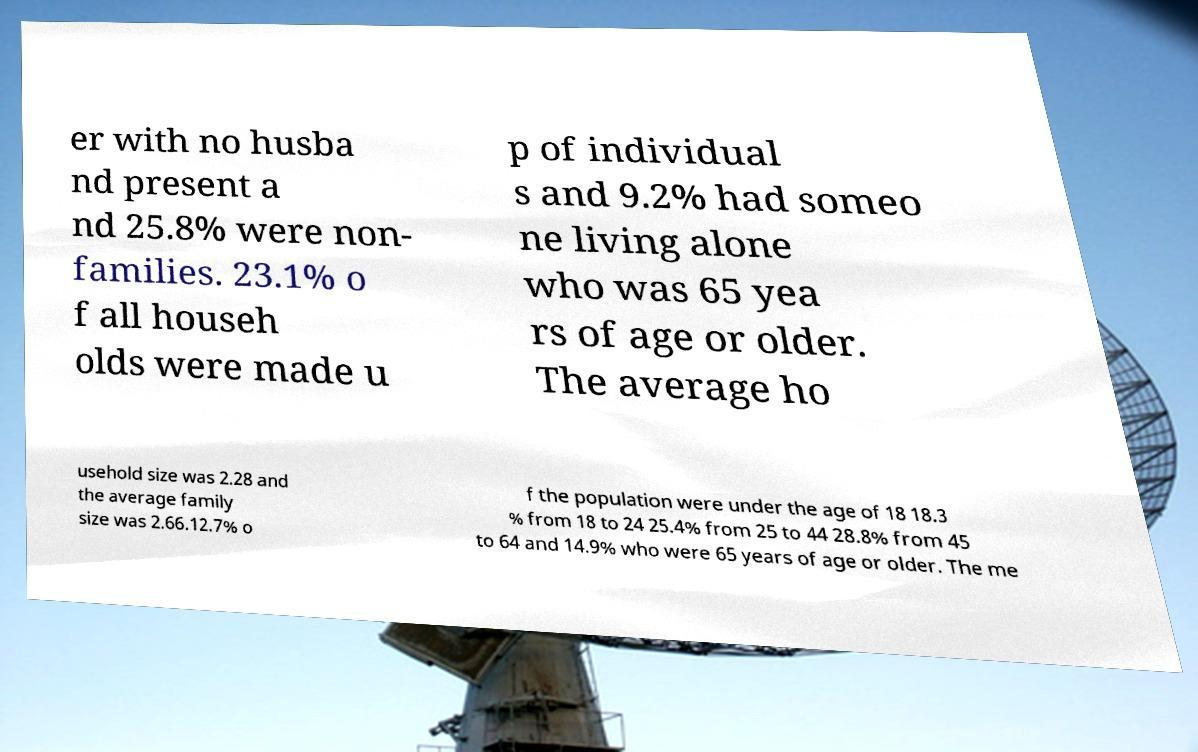For documentation purposes, I need the text within this image transcribed. Could you provide that? er with no husba nd present a nd 25.8% were non- families. 23.1% o f all househ olds were made u p of individual s and 9.2% had someo ne living alone who was 65 yea rs of age or older. The average ho usehold size was 2.28 and the average family size was 2.66.12.7% o f the population were under the age of 18 18.3 % from 18 to 24 25.4% from 25 to 44 28.8% from 45 to 64 and 14.9% who were 65 years of age or older. The me 